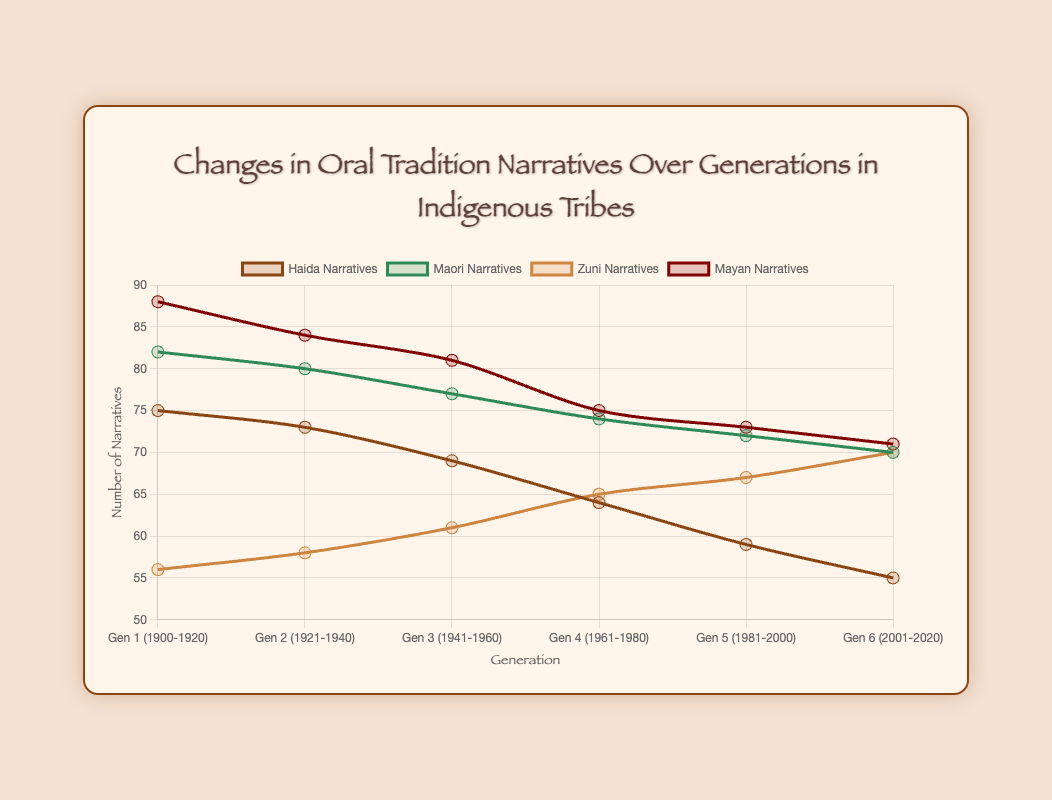Which generation had the highest number of Mayan Narratives? To identify the generation with the highest number of Mayan Narratives, observe the data points for the Mayan Narratives line and find the peak. According to the chart, the highest number of Mayan Narratives is 88 in the generation "Gen 1 (1900-1920)".
Answer: Gen 1 (1900-1920) Which tribe had the most significant increase in narratives between Generation 1 and Generation 6? To determine the tribe with the most significant increase, calculate the difference in narratives between Generation 1 and Generation 6 for each tribe. The increase can be found by subtracting the Generation 1 value from the Generation 6 value. Haida: 55 - 75 = -20, Maori: 70 - 82 = -12, Zuni: 70 - 56 = 14, Mayan: 71 - 88 = -17. The Zuni tribe shows the most significant increase of 14 narratives.
Answer: Zuni What is the average number of Haida Narratives across all generations? To find the average number of Haida Narratives, add the narrative numbers of all generations and divide by the number of generations. The sum is 75 + 73 + 69 + 64 + 59 + 55 = 395. There are 6 generations, so the average is 395/6 = 65.83.
Answer: 65.83 Which generation shows the biggest decrease in Maori Narratives compared to its previous generation? To determine the biggest decrease, calculate the decrease between consecutive generations for Maori Narratives. Gen 1 to Gen 2: 82 - 80 = 2, Gen 2 to Gen 3: 80 - 77 = 3, Gen 3 to Gen 4: 77 - 74 = 3, Gen 4 to Gen 5: 74 - 72 = 2, Gen 5 to Gen 6: 72 - 70 = 2. The biggest decrease is 3 narratives from Gen 2 to Gen 3 and from Gen 3 to Gen 4.
Answer: Gen 2 to Gen 3, Gen 3 to Gen 4 In which generation do Zuni Narratives surpass Haida Narratives for the first time? Compare the data points for Zuni and Haida Narratives generation by generation. Zuni Narratives first exceed Haida Narratives in Generation 5 (1981-2000) where Zuni has 67 narratives and Haida has 59.
Answer: Gen 5 (1981-2000) Which tribe shows the most stable trend in narratives over the generations? To identify the most stable trend, look at the variance in the data points across generations for each tribe. The Zuni tribe shows a steady increase from 56 to 70 narratives over the generations without large fluctuations. This pattern indicates stability.
Answer: Zuni How many more narratives did the Haida tribe have compared to the Zuni tribe in Generation 3? To find the difference, subtract the number of Zuni Narratives from Haida Narratives in Generation 3. Haida Narratives were 69, and Zuni Narratives were 61 in Generation 3. The difference is 69 - 61 = 8.
Answer: 8 What is the total number of Maori Narratives across all generations? To find the total number of Maori Narratives, sum the values of all generations. The total is 82 + 80 + 77 + 74 + 72 + 70 = 455.
Answer: 455 How much did the number of Mayan Narratives decrease from Generation 1 to Generation 6? To find the decrease, subtract the number of Mayan Narratives in Generation 6 from Generation 1. Mayan Narratives were 88 in Generation 1 and 71 in Generation 6. The decrease is 88 - 71 = 17.
Answer: 17 